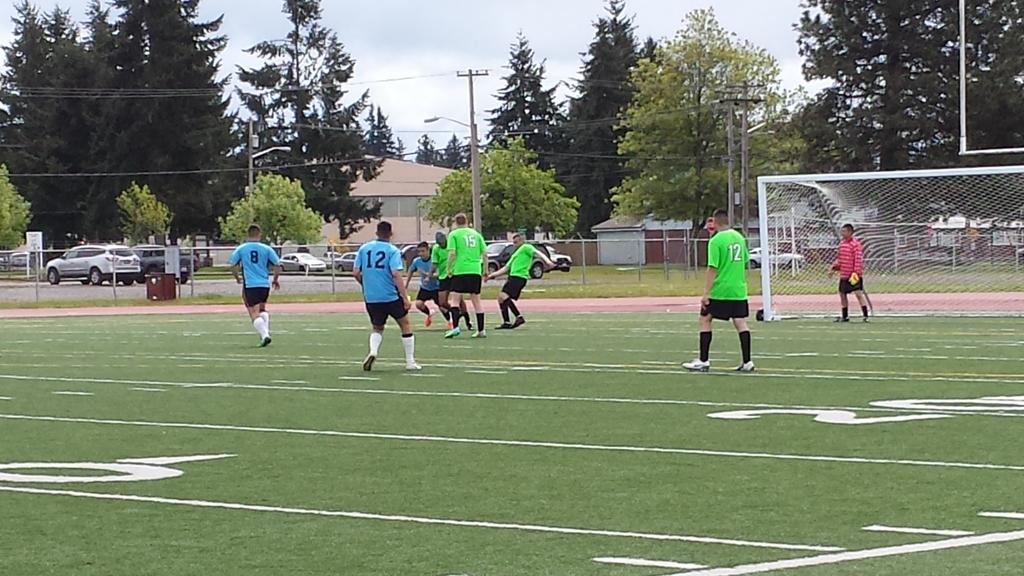What number is shared by the two players closest to the camera?
Provide a succinct answer. 12. What is the number of the player on the left?
Keep it short and to the point. 8. 